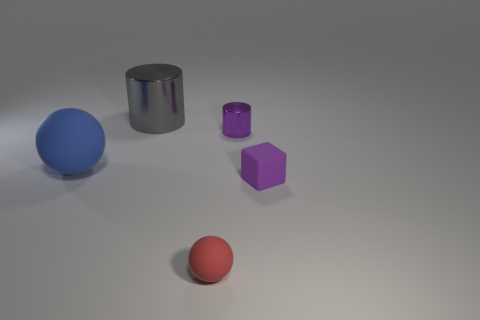What number of small rubber blocks are the same color as the tiny metallic thing?
Offer a very short reply. 1. Do the rubber cube and the big metallic thing have the same color?
Keep it short and to the point. No. How many matte objects are gray cubes or large objects?
Keep it short and to the point. 1. What number of rubber objects are there?
Keep it short and to the point. 3. Does the thing on the left side of the large cylinder have the same material as the red thing on the left side of the small rubber cube?
Provide a succinct answer. Yes. The other metal thing that is the same shape as the tiny metal object is what color?
Offer a terse response. Gray. There is a small purple thing in front of the tiny metallic thing that is on the right side of the large blue sphere; what is it made of?
Provide a succinct answer. Rubber. Does the small rubber thing behind the red sphere have the same shape as the tiny thing behind the small purple block?
Ensure brevity in your answer.  No. What is the size of the object that is on the left side of the tiny red rubber sphere and in front of the big gray metallic object?
Give a very brief answer. Large. How many other things are there of the same color as the big cylinder?
Offer a very short reply. 0. 